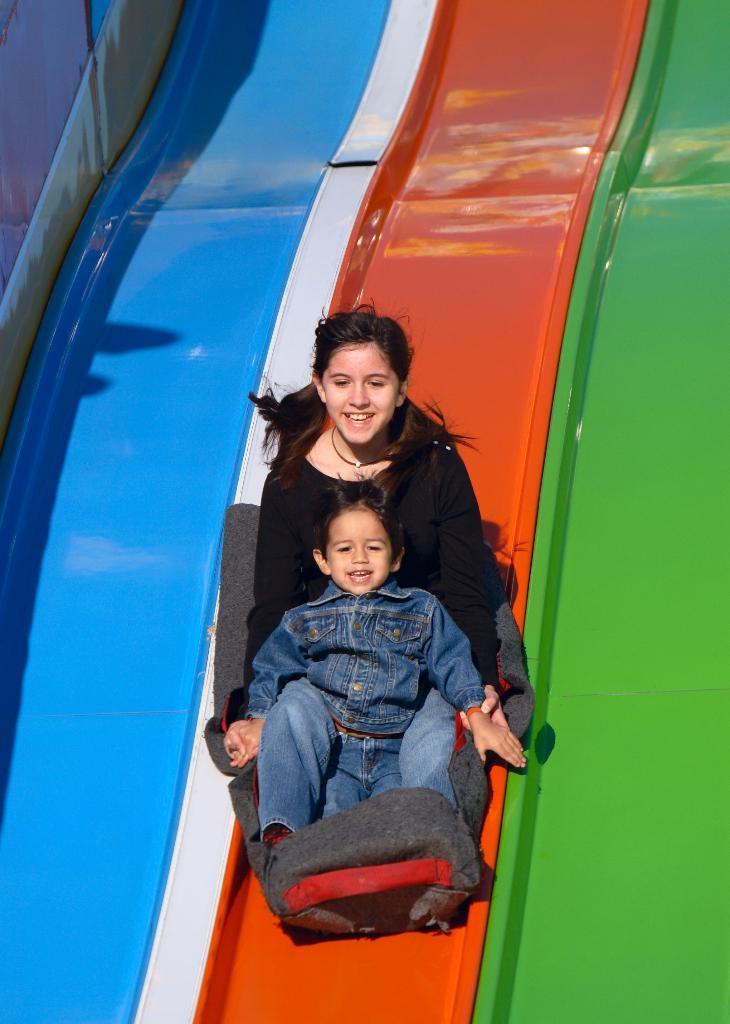In one or two sentences, can you explain what this image depicts? In this picture we can see a girl, boy sitting on a float chair and in the background we can see slides. 